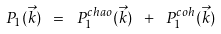<formula> <loc_0><loc_0><loc_500><loc_500>P _ { 1 } ( \vec { k } ) \ = \ P _ { 1 } ^ { c h a o } ( \vec { k } ) \ + \ P _ { 1 } ^ { c o h } ( \vec { k } )</formula> 